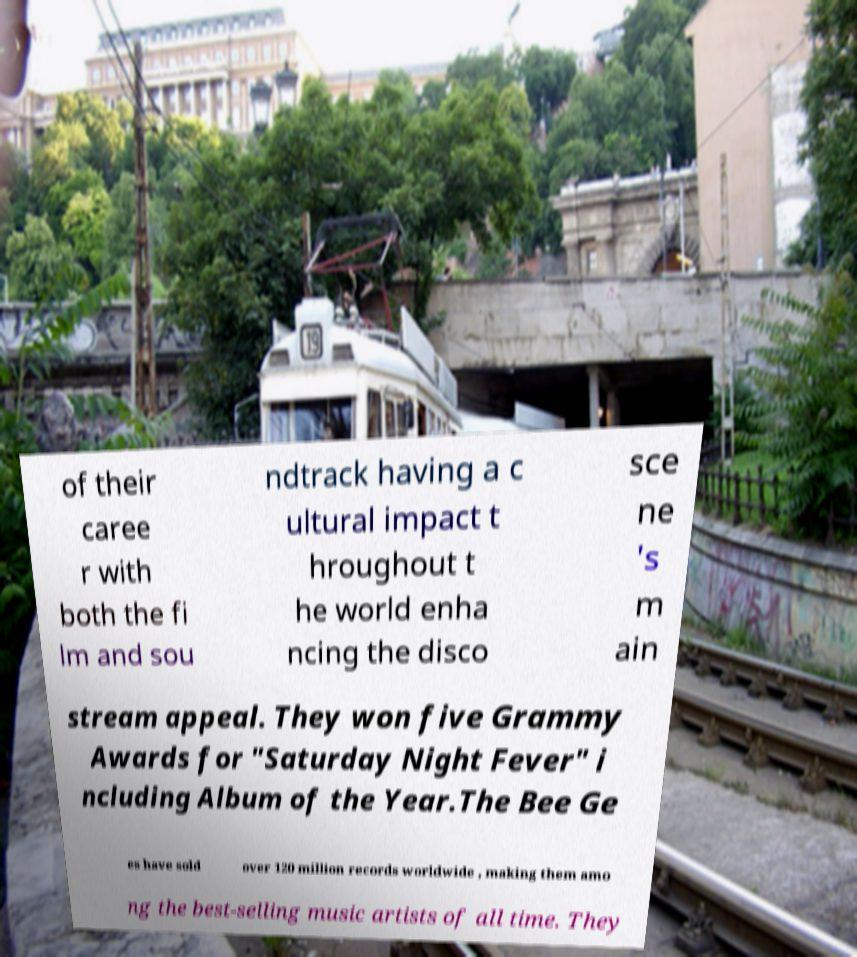There's text embedded in this image that I need extracted. Can you transcribe it verbatim? of their caree r with both the fi lm and sou ndtrack having a c ultural impact t hroughout t he world enha ncing the disco sce ne 's m ain stream appeal. They won five Grammy Awards for "Saturday Night Fever" i ncluding Album of the Year.The Bee Ge es have sold over 120 million records worldwide , making them amo ng the best-selling music artists of all time. They 